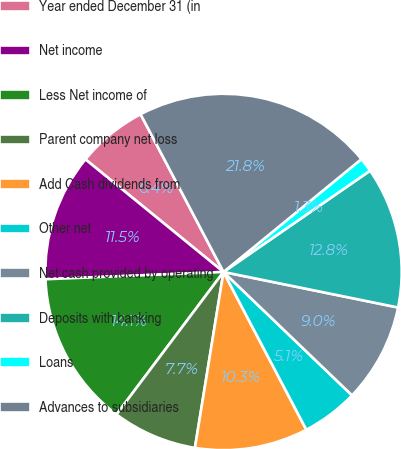Convert chart to OTSL. <chart><loc_0><loc_0><loc_500><loc_500><pie_chart><fcel>Year ended December 31 (in<fcel>Net income<fcel>Less Net income of<fcel>Parent company net loss<fcel>Add Cash dividends from<fcel>Other net<fcel>Net cash provided by operating<fcel>Deposits with banking<fcel>Loans<fcel>Advances to subsidiaries<nl><fcel>6.41%<fcel>11.54%<fcel>14.1%<fcel>7.69%<fcel>10.26%<fcel>5.13%<fcel>8.98%<fcel>12.82%<fcel>1.29%<fcel>21.79%<nl></chart> 